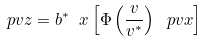Convert formula to latex. <formula><loc_0><loc_0><loc_500><loc_500>\ p { v } { z } = b ^ { * } \ { x } \left [ \Phi \left ( \frac { v } { v ^ { * } } \right ) \ p { v } { x } \right ]</formula> 